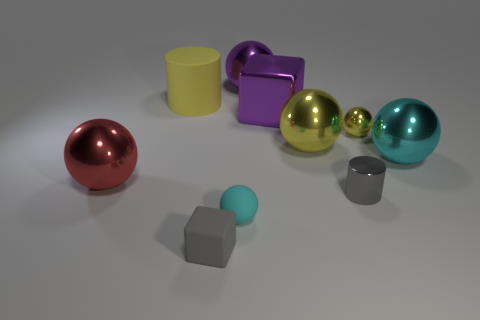Subtract all small balls. How many balls are left? 4 Subtract all red balls. How many balls are left? 5 Subtract all blue balls. Subtract all gray cubes. How many balls are left? 6 Subtract all balls. How many objects are left? 4 Subtract 0 cyan blocks. How many objects are left? 10 Subtract all red metallic balls. Subtract all purple spheres. How many objects are left? 8 Add 8 small matte objects. How many small matte objects are left? 10 Add 1 small yellow matte things. How many small yellow matte things exist? 1 